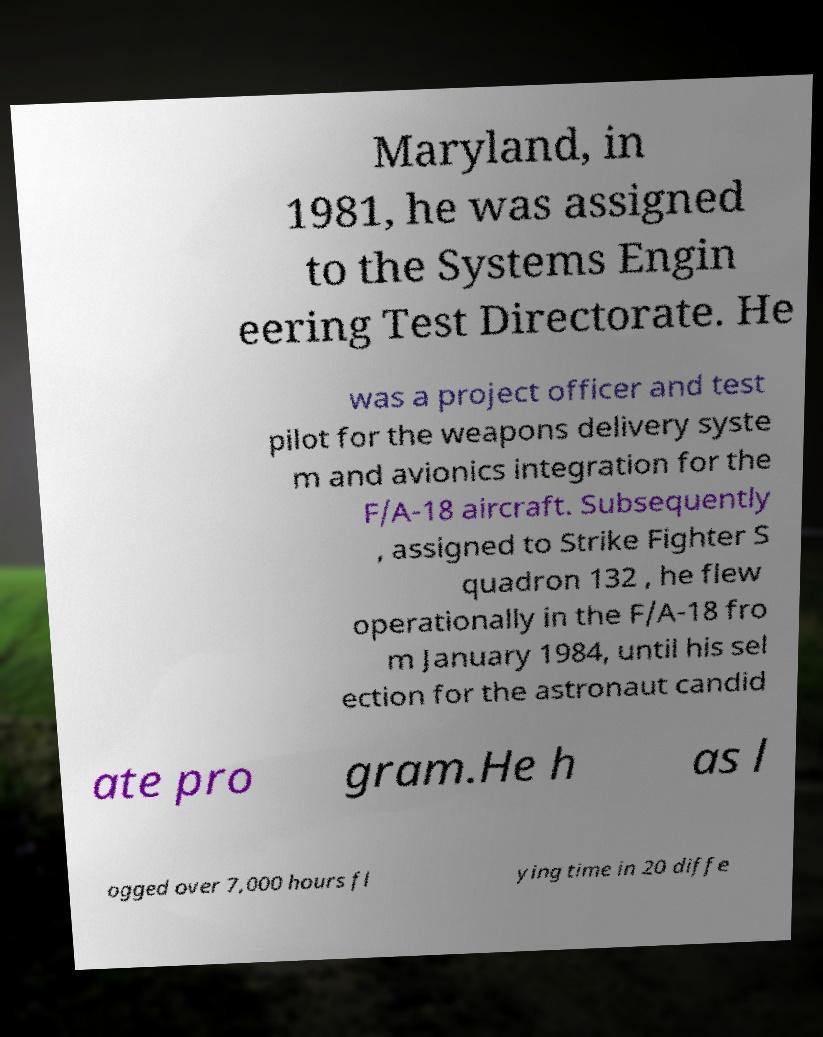I need the written content from this picture converted into text. Can you do that? Maryland, in 1981, he was assigned to the Systems Engin eering Test Directorate. He was a project officer and test pilot for the weapons delivery syste m and avionics integration for the F/A-18 aircraft. Subsequently , assigned to Strike Fighter S quadron 132 , he flew operationally in the F/A-18 fro m January 1984, until his sel ection for the astronaut candid ate pro gram.He h as l ogged over 7,000 hours fl ying time in 20 diffe 